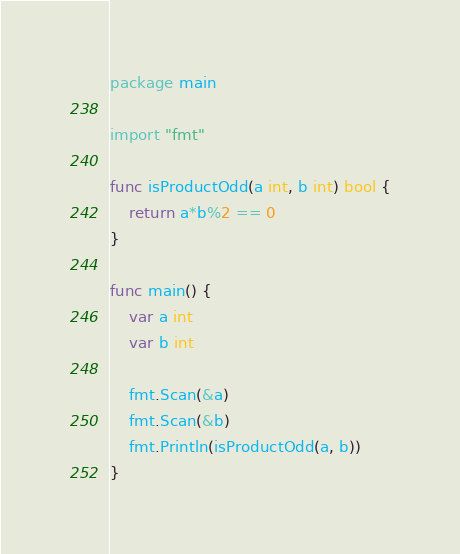Convert code to text. <code><loc_0><loc_0><loc_500><loc_500><_Go_>package main

import "fmt"

func isProductOdd(a int, b int) bool {
	return a*b%2 == 0
}

func main() {
	var a int
	var b int

	fmt.Scan(&a)
	fmt.Scan(&b)
	fmt.Println(isProductOdd(a, b))
}
</code> 